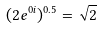<formula> <loc_0><loc_0><loc_500><loc_500>( 2 e ^ { 0 i } ) ^ { 0 . 5 } = \sqrt { 2 }</formula> 